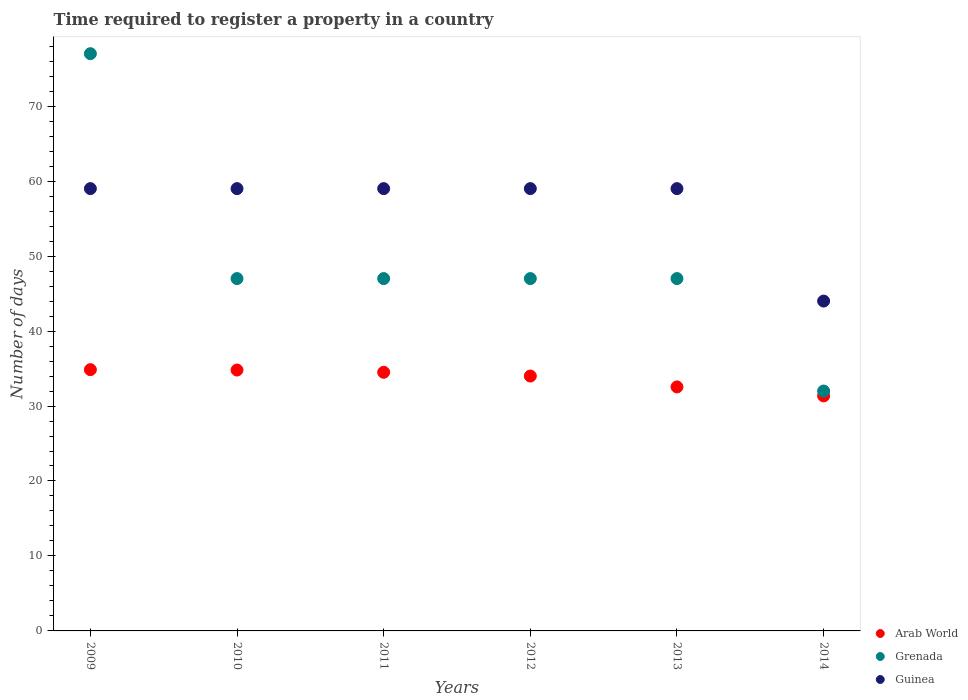What is the number of days required to register a property in Guinea in 2011?
Your response must be concise. 59. Across all years, what is the maximum number of days required to register a property in Arab World?
Provide a short and direct response. 34.85. Across all years, what is the minimum number of days required to register a property in Guinea?
Give a very brief answer. 44. In which year was the number of days required to register a property in Guinea maximum?
Offer a terse response. 2009. In which year was the number of days required to register a property in Arab World minimum?
Your answer should be very brief. 2014. What is the total number of days required to register a property in Guinea in the graph?
Make the answer very short. 339. What is the difference between the number of days required to register a property in Guinea in 2009 and that in 2014?
Provide a short and direct response. 15. What is the difference between the number of days required to register a property in Arab World in 2011 and the number of days required to register a property in Guinea in 2010?
Provide a succinct answer. -24.5. What is the average number of days required to register a property in Guinea per year?
Provide a succinct answer. 56.5. In how many years, is the number of days required to register a property in Guinea greater than 2 days?
Provide a succinct answer. 6. What is the ratio of the number of days required to register a property in Arab World in 2012 to that in 2013?
Your response must be concise. 1.04. What is the difference between the highest and the second highest number of days required to register a property in Arab World?
Provide a short and direct response. 0.05. Is the sum of the number of days required to register a property in Grenada in 2009 and 2013 greater than the maximum number of days required to register a property in Guinea across all years?
Provide a succinct answer. Yes. Is it the case that in every year, the sum of the number of days required to register a property in Arab World and number of days required to register a property in Guinea  is greater than the number of days required to register a property in Grenada?
Offer a terse response. Yes. Is the number of days required to register a property in Arab World strictly greater than the number of days required to register a property in Guinea over the years?
Provide a short and direct response. No. How many years are there in the graph?
Provide a short and direct response. 6. Are the values on the major ticks of Y-axis written in scientific E-notation?
Your response must be concise. No. Does the graph contain grids?
Offer a terse response. No. How are the legend labels stacked?
Your answer should be very brief. Vertical. What is the title of the graph?
Your response must be concise. Time required to register a property in a country. Does "European Union" appear as one of the legend labels in the graph?
Offer a very short reply. No. What is the label or title of the X-axis?
Provide a short and direct response. Years. What is the label or title of the Y-axis?
Your response must be concise. Number of days. What is the Number of days of Arab World in 2009?
Ensure brevity in your answer.  34.85. What is the Number of days in Grenada in 2009?
Ensure brevity in your answer.  77. What is the Number of days in Arab World in 2010?
Your answer should be compact. 34.8. What is the Number of days in Grenada in 2010?
Offer a very short reply. 47. What is the Number of days in Arab World in 2011?
Your answer should be very brief. 34.5. What is the Number of days in Guinea in 2011?
Provide a succinct answer. 59. What is the Number of days of Arab World in 2012?
Your answer should be very brief. 34. What is the Number of days of Arab World in 2013?
Offer a terse response. 32.55. What is the Number of days of Grenada in 2013?
Make the answer very short. 47. What is the Number of days in Arab World in 2014?
Ensure brevity in your answer.  31.35. What is the Number of days of Grenada in 2014?
Give a very brief answer. 32. Across all years, what is the maximum Number of days of Arab World?
Your answer should be very brief. 34.85. Across all years, what is the maximum Number of days in Grenada?
Ensure brevity in your answer.  77. Across all years, what is the minimum Number of days of Arab World?
Your answer should be compact. 31.35. Across all years, what is the minimum Number of days in Guinea?
Keep it short and to the point. 44. What is the total Number of days of Arab World in the graph?
Offer a terse response. 202.05. What is the total Number of days of Grenada in the graph?
Give a very brief answer. 297. What is the total Number of days in Guinea in the graph?
Ensure brevity in your answer.  339. What is the difference between the Number of days of Arab World in 2009 and that in 2010?
Give a very brief answer. 0.05. What is the difference between the Number of days in Grenada in 2009 and that in 2010?
Provide a short and direct response. 30. What is the difference between the Number of days in Arab World in 2009 and that in 2011?
Make the answer very short. 0.35. What is the difference between the Number of days in Grenada in 2009 and that in 2011?
Keep it short and to the point. 30. What is the difference between the Number of days of Guinea in 2009 and that in 2011?
Provide a short and direct response. 0. What is the difference between the Number of days of Arab World in 2009 and that in 2012?
Your answer should be compact. 0.85. What is the difference between the Number of days in Grenada in 2009 and that in 2012?
Your response must be concise. 30. What is the difference between the Number of days of Grenada in 2009 and that in 2013?
Your response must be concise. 30. What is the difference between the Number of days in Grenada in 2009 and that in 2014?
Provide a short and direct response. 45. What is the difference between the Number of days of Arab World in 2010 and that in 2011?
Keep it short and to the point. 0.3. What is the difference between the Number of days in Grenada in 2010 and that in 2012?
Provide a short and direct response. 0. What is the difference between the Number of days in Arab World in 2010 and that in 2013?
Make the answer very short. 2.25. What is the difference between the Number of days in Grenada in 2010 and that in 2013?
Offer a terse response. 0. What is the difference between the Number of days of Guinea in 2010 and that in 2013?
Your answer should be very brief. 0. What is the difference between the Number of days of Arab World in 2010 and that in 2014?
Keep it short and to the point. 3.45. What is the difference between the Number of days in Guinea in 2010 and that in 2014?
Offer a terse response. 15. What is the difference between the Number of days of Arab World in 2011 and that in 2013?
Provide a succinct answer. 1.95. What is the difference between the Number of days of Guinea in 2011 and that in 2013?
Give a very brief answer. 0. What is the difference between the Number of days in Arab World in 2011 and that in 2014?
Offer a terse response. 3.15. What is the difference between the Number of days in Grenada in 2011 and that in 2014?
Your response must be concise. 15. What is the difference between the Number of days in Arab World in 2012 and that in 2013?
Offer a terse response. 1.45. What is the difference between the Number of days of Arab World in 2012 and that in 2014?
Your answer should be very brief. 2.65. What is the difference between the Number of days in Guinea in 2012 and that in 2014?
Provide a succinct answer. 15. What is the difference between the Number of days in Arab World in 2013 and that in 2014?
Offer a terse response. 1.2. What is the difference between the Number of days in Grenada in 2013 and that in 2014?
Offer a very short reply. 15. What is the difference between the Number of days in Guinea in 2013 and that in 2014?
Ensure brevity in your answer.  15. What is the difference between the Number of days of Arab World in 2009 and the Number of days of Grenada in 2010?
Keep it short and to the point. -12.15. What is the difference between the Number of days of Arab World in 2009 and the Number of days of Guinea in 2010?
Your answer should be very brief. -24.15. What is the difference between the Number of days of Grenada in 2009 and the Number of days of Guinea in 2010?
Offer a terse response. 18. What is the difference between the Number of days in Arab World in 2009 and the Number of days in Grenada in 2011?
Keep it short and to the point. -12.15. What is the difference between the Number of days of Arab World in 2009 and the Number of days of Guinea in 2011?
Give a very brief answer. -24.15. What is the difference between the Number of days of Grenada in 2009 and the Number of days of Guinea in 2011?
Your response must be concise. 18. What is the difference between the Number of days of Arab World in 2009 and the Number of days of Grenada in 2012?
Provide a short and direct response. -12.15. What is the difference between the Number of days of Arab World in 2009 and the Number of days of Guinea in 2012?
Keep it short and to the point. -24.15. What is the difference between the Number of days in Grenada in 2009 and the Number of days in Guinea in 2012?
Your answer should be compact. 18. What is the difference between the Number of days of Arab World in 2009 and the Number of days of Grenada in 2013?
Provide a short and direct response. -12.15. What is the difference between the Number of days of Arab World in 2009 and the Number of days of Guinea in 2013?
Your answer should be compact. -24.15. What is the difference between the Number of days of Grenada in 2009 and the Number of days of Guinea in 2013?
Keep it short and to the point. 18. What is the difference between the Number of days of Arab World in 2009 and the Number of days of Grenada in 2014?
Your answer should be very brief. 2.85. What is the difference between the Number of days of Arab World in 2009 and the Number of days of Guinea in 2014?
Make the answer very short. -9.15. What is the difference between the Number of days of Grenada in 2009 and the Number of days of Guinea in 2014?
Ensure brevity in your answer.  33. What is the difference between the Number of days of Arab World in 2010 and the Number of days of Guinea in 2011?
Make the answer very short. -24.2. What is the difference between the Number of days of Grenada in 2010 and the Number of days of Guinea in 2011?
Provide a short and direct response. -12. What is the difference between the Number of days of Arab World in 2010 and the Number of days of Guinea in 2012?
Offer a terse response. -24.2. What is the difference between the Number of days in Arab World in 2010 and the Number of days in Guinea in 2013?
Offer a very short reply. -24.2. What is the difference between the Number of days of Grenada in 2010 and the Number of days of Guinea in 2013?
Your answer should be compact. -12. What is the difference between the Number of days of Grenada in 2010 and the Number of days of Guinea in 2014?
Provide a short and direct response. 3. What is the difference between the Number of days of Arab World in 2011 and the Number of days of Grenada in 2012?
Your answer should be very brief. -12.5. What is the difference between the Number of days of Arab World in 2011 and the Number of days of Guinea in 2012?
Your answer should be compact. -24.5. What is the difference between the Number of days in Grenada in 2011 and the Number of days in Guinea in 2012?
Your answer should be very brief. -12. What is the difference between the Number of days in Arab World in 2011 and the Number of days in Guinea in 2013?
Provide a short and direct response. -24.5. What is the difference between the Number of days in Grenada in 2011 and the Number of days in Guinea in 2014?
Offer a terse response. 3. What is the difference between the Number of days in Arab World in 2012 and the Number of days in Grenada in 2013?
Your answer should be very brief. -13. What is the difference between the Number of days in Arab World in 2012 and the Number of days in Guinea in 2013?
Ensure brevity in your answer.  -25. What is the difference between the Number of days of Arab World in 2012 and the Number of days of Grenada in 2014?
Keep it short and to the point. 2. What is the difference between the Number of days in Grenada in 2012 and the Number of days in Guinea in 2014?
Your answer should be very brief. 3. What is the difference between the Number of days in Arab World in 2013 and the Number of days in Grenada in 2014?
Provide a short and direct response. 0.55. What is the difference between the Number of days of Arab World in 2013 and the Number of days of Guinea in 2014?
Your response must be concise. -11.45. What is the difference between the Number of days in Grenada in 2013 and the Number of days in Guinea in 2014?
Your answer should be compact. 3. What is the average Number of days in Arab World per year?
Offer a very short reply. 33.67. What is the average Number of days in Grenada per year?
Ensure brevity in your answer.  49.5. What is the average Number of days of Guinea per year?
Your response must be concise. 56.5. In the year 2009, what is the difference between the Number of days of Arab World and Number of days of Grenada?
Your response must be concise. -42.15. In the year 2009, what is the difference between the Number of days in Arab World and Number of days in Guinea?
Offer a very short reply. -24.15. In the year 2009, what is the difference between the Number of days of Grenada and Number of days of Guinea?
Ensure brevity in your answer.  18. In the year 2010, what is the difference between the Number of days in Arab World and Number of days in Grenada?
Provide a short and direct response. -12.2. In the year 2010, what is the difference between the Number of days in Arab World and Number of days in Guinea?
Your response must be concise. -24.2. In the year 2010, what is the difference between the Number of days in Grenada and Number of days in Guinea?
Your response must be concise. -12. In the year 2011, what is the difference between the Number of days in Arab World and Number of days in Guinea?
Provide a short and direct response. -24.5. In the year 2011, what is the difference between the Number of days in Grenada and Number of days in Guinea?
Your answer should be very brief. -12. In the year 2012, what is the difference between the Number of days of Grenada and Number of days of Guinea?
Your answer should be very brief. -12. In the year 2013, what is the difference between the Number of days in Arab World and Number of days in Grenada?
Offer a very short reply. -14.45. In the year 2013, what is the difference between the Number of days of Arab World and Number of days of Guinea?
Make the answer very short. -26.45. In the year 2013, what is the difference between the Number of days of Grenada and Number of days of Guinea?
Provide a short and direct response. -12. In the year 2014, what is the difference between the Number of days in Arab World and Number of days in Grenada?
Your answer should be very brief. -0.65. In the year 2014, what is the difference between the Number of days of Arab World and Number of days of Guinea?
Offer a very short reply. -12.65. In the year 2014, what is the difference between the Number of days of Grenada and Number of days of Guinea?
Provide a short and direct response. -12. What is the ratio of the Number of days of Grenada in 2009 to that in 2010?
Ensure brevity in your answer.  1.64. What is the ratio of the Number of days in Guinea in 2009 to that in 2010?
Make the answer very short. 1. What is the ratio of the Number of days in Arab World in 2009 to that in 2011?
Give a very brief answer. 1.01. What is the ratio of the Number of days in Grenada in 2009 to that in 2011?
Your response must be concise. 1.64. What is the ratio of the Number of days of Guinea in 2009 to that in 2011?
Your response must be concise. 1. What is the ratio of the Number of days of Arab World in 2009 to that in 2012?
Keep it short and to the point. 1.02. What is the ratio of the Number of days of Grenada in 2009 to that in 2012?
Your response must be concise. 1.64. What is the ratio of the Number of days in Arab World in 2009 to that in 2013?
Give a very brief answer. 1.07. What is the ratio of the Number of days in Grenada in 2009 to that in 2013?
Keep it short and to the point. 1.64. What is the ratio of the Number of days in Guinea in 2009 to that in 2013?
Provide a succinct answer. 1. What is the ratio of the Number of days in Arab World in 2009 to that in 2014?
Provide a succinct answer. 1.11. What is the ratio of the Number of days of Grenada in 2009 to that in 2014?
Your answer should be compact. 2.41. What is the ratio of the Number of days of Guinea in 2009 to that in 2014?
Your response must be concise. 1.34. What is the ratio of the Number of days of Arab World in 2010 to that in 2011?
Provide a short and direct response. 1.01. What is the ratio of the Number of days in Grenada in 2010 to that in 2011?
Your answer should be compact. 1. What is the ratio of the Number of days in Guinea in 2010 to that in 2011?
Your answer should be very brief. 1. What is the ratio of the Number of days in Arab World in 2010 to that in 2012?
Offer a terse response. 1.02. What is the ratio of the Number of days in Guinea in 2010 to that in 2012?
Make the answer very short. 1. What is the ratio of the Number of days in Arab World in 2010 to that in 2013?
Your answer should be compact. 1.07. What is the ratio of the Number of days of Guinea in 2010 to that in 2013?
Ensure brevity in your answer.  1. What is the ratio of the Number of days of Arab World in 2010 to that in 2014?
Give a very brief answer. 1.11. What is the ratio of the Number of days in Grenada in 2010 to that in 2014?
Provide a short and direct response. 1.47. What is the ratio of the Number of days of Guinea in 2010 to that in 2014?
Your answer should be compact. 1.34. What is the ratio of the Number of days in Arab World in 2011 to that in 2012?
Give a very brief answer. 1.01. What is the ratio of the Number of days of Grenada in 2011 to that in 2012?
Provide a short and direct response. 1. What is the ratio of the Number of days in Guinea in 2011 to that in 2012?
Your answer should be compact. 1. What is the ratio of the Number of days in Arab World in 2011 to that in 2013?
Your answer should be very brief. 1.06. What is the ratio of the Number of days in Grenada in 2011 to that in 2013?
Keep it short and to the point. 1. What is the ratio of the Number of days in Arab World in 2011 to that in 2014?
Make the answer very short. 1.1. What is the ratio of the Number of days of Grenada in 2011 to that in 2014?
Keep it short and to the point. 1.47. What is the ratio of the Number of days in Guinea in 2011 to that in 2014?
Provide a succinct answer. 1.34. What is the ratio of the Number of days of Arab World in 2012 to that in 2013?
Your answer should be very brief. 1.04. What is the ratio of the Number of days in Arab World in 2012 to that in 2014?
Offer a very short reply. 1.08. What is the ratio of the Number of days of Grenada in 2012 to that in 2014?
Your response must be concise. 1.47. What is the ratio of the Number of days in Guinea in 2012 to that in 2014?
Ensure brevity in your answer.  1.34. What is the ratio of the Number of days in Arab World in 2013 to that in 2014?
Ensure brevity in your answer.  1.04. What is the ratio of the Number of days of Grenada in 2013 to that in 2014?
Your answer should be compact. 1.47. What is the ratio of the Number of days in Guinea in 2013 to that in 2014?
Offer a very short reply. 1.34. What is the difference between the highest and the second highest Number of days of Grenada?
Your answer should be compact. 30. What is the difference between the highest and the second highest Number of days of Guinea?
Give a very brief answer. 0. 